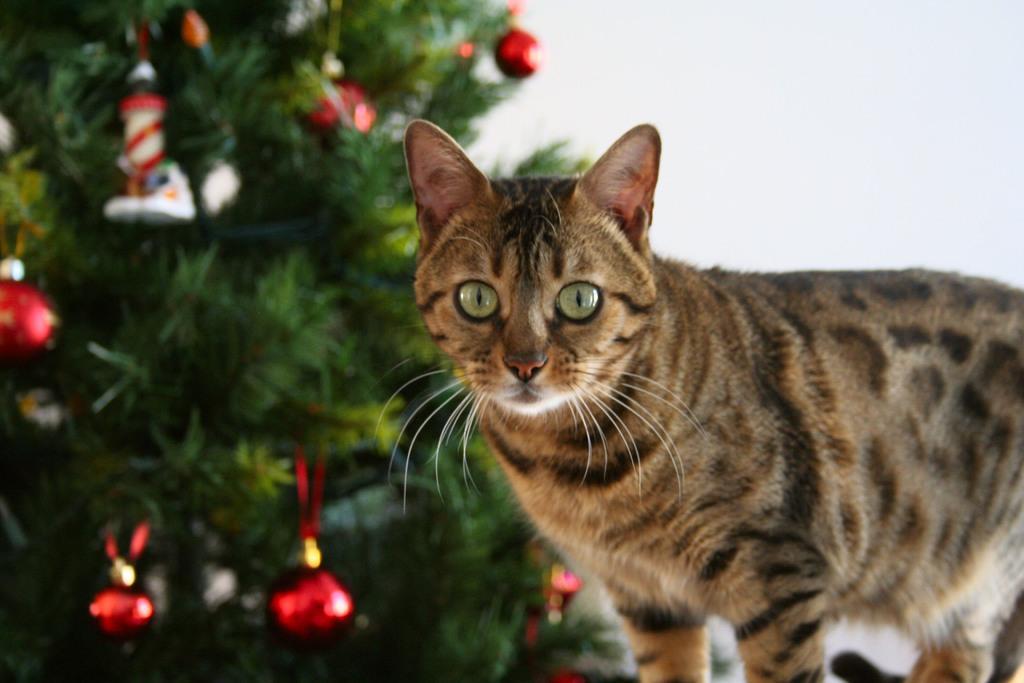Can you describe this image briefly? In this picture we can see cat, leaves and decorative objects. In the background of the image it is white. 